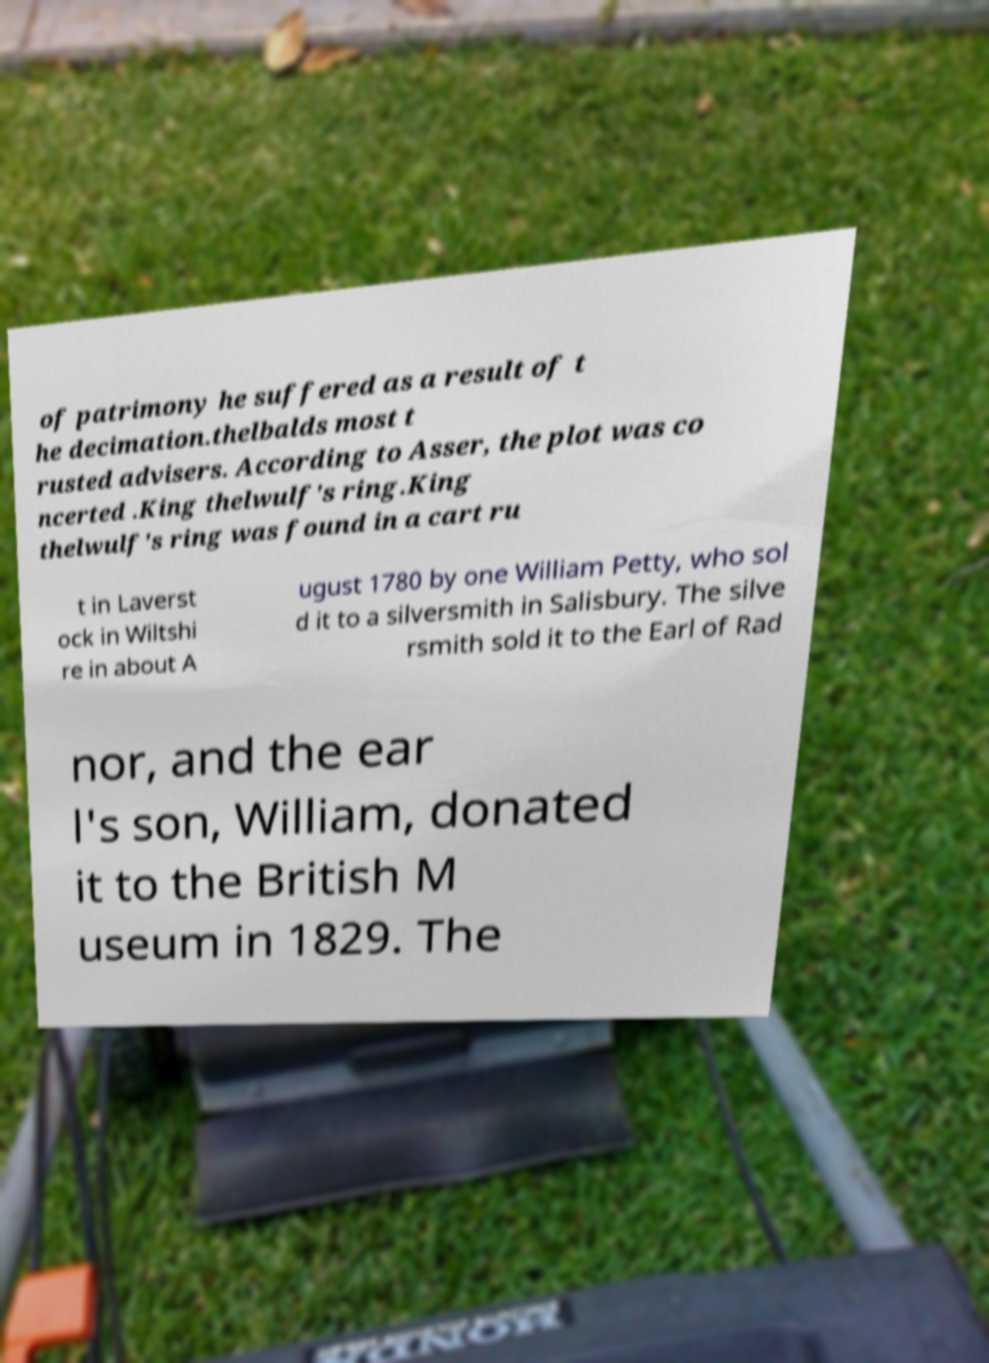There's text embedded in this image that I need extracted. Can you transcribe it verbatim? of patrimony he suffered as a result of t he decimation.thelbalds most t rusted advisers. According to Asser, the plot was co ncerted .King thelwulf's ring.King thelwulf's ring was found in a cart ru t in Laverst ock in Wiltshi re in about A ugust 1780 by one William Petty, who sol d it to a silversmith in Salisbury. The silve rsmith sold it to the Earl of Rad nor, and the ear l's son, William, donated it to the British M useum in 1829. The 